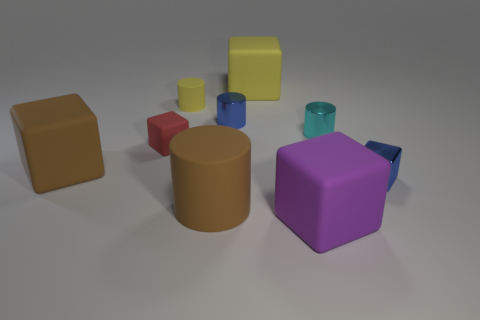Are any big purple shiny cubes visible?
Your answer should be very brief. No. Is the shape of the purple rubber thing the same as the large yellow object?
Provide a succinct answer. Yes. What number of yellow things are on the left side of the yellow rubber thing right of the blue object to the left of the purple matte thing?
Provide a short and direct response. 1. What is the large object that is both behind the purple cube and to the right of the tiny blue metal cylinder made of?
Make the answer very short. Rubber. What color is the large cube that is in front of the tiny yellow cylinder and to the right of the red matte thing?
Your answer should be very brief. Purple. Are there any other things that are the same color as the big cylinder?
Make the answer very short. Yes. What is the shape of the blue thing behind the brown rubber thing left of the cylinder that is in front of the small matte cube?
Your response must be concise. Cylinder. What color is the large thing that is the same shape as the small yellow object?
Make the answer very short. Brown. What color is the small cube left of the blue shiny object right of the purple rubber cube?
Your answer should be very brief. Red. What is the size of the brown thing that is the same shape as the large yellow thing?
Give a very brief answer. Large. 